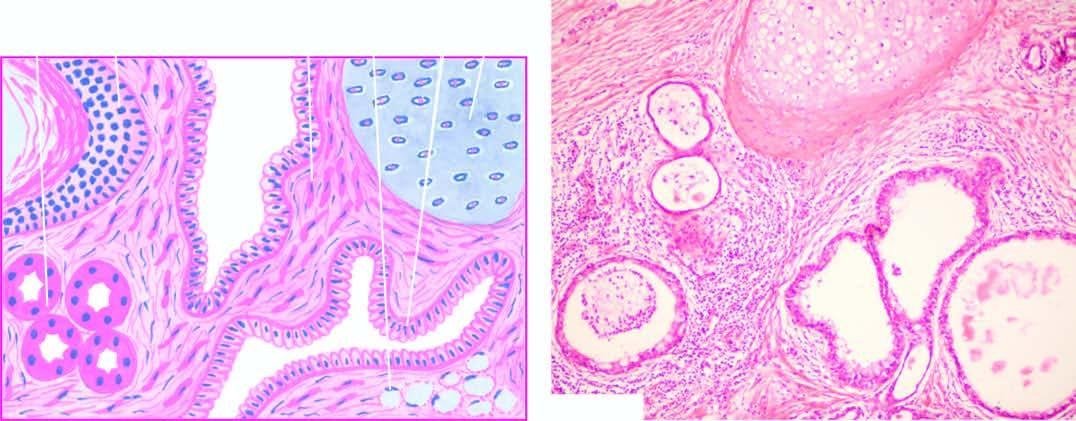how does microscopy show characteristic lining of the cyst wall?
Answer the question using a single word or phrase. By epidermis and its appendages 